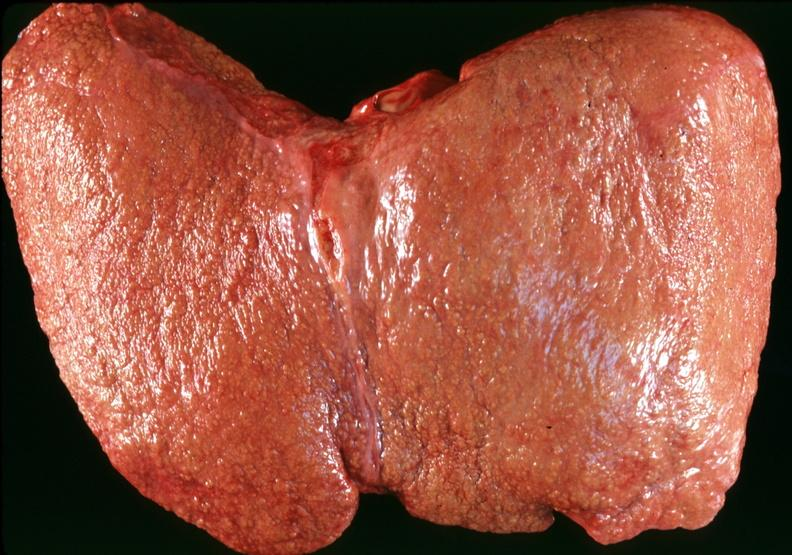does this good yellow color slide show cirrhosis?
Answer the question using a single word or phrase. No 